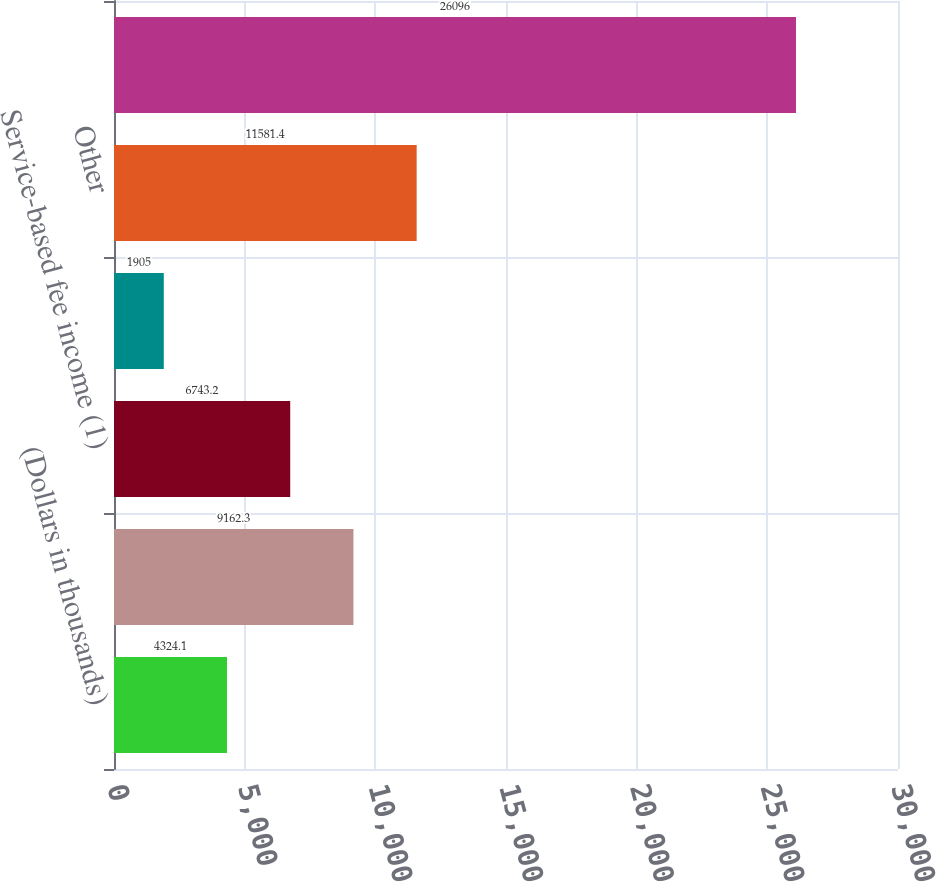<chart> <loc_0><loc_0><loc_500><loc_500><bar_chart><fcel>(Dollars in thousands)<fcel>Fund management fees<fcel>Service-based fee income (1)<fcel>Gains (losses) on foreign<fcel>Other<fcel>Total other noninterest income<nl><fcel>4324.1<fcel>9162.3<fcel>6743.2<fcel>1905<fcel>11581.4<fcel>26096<nl></chart> 